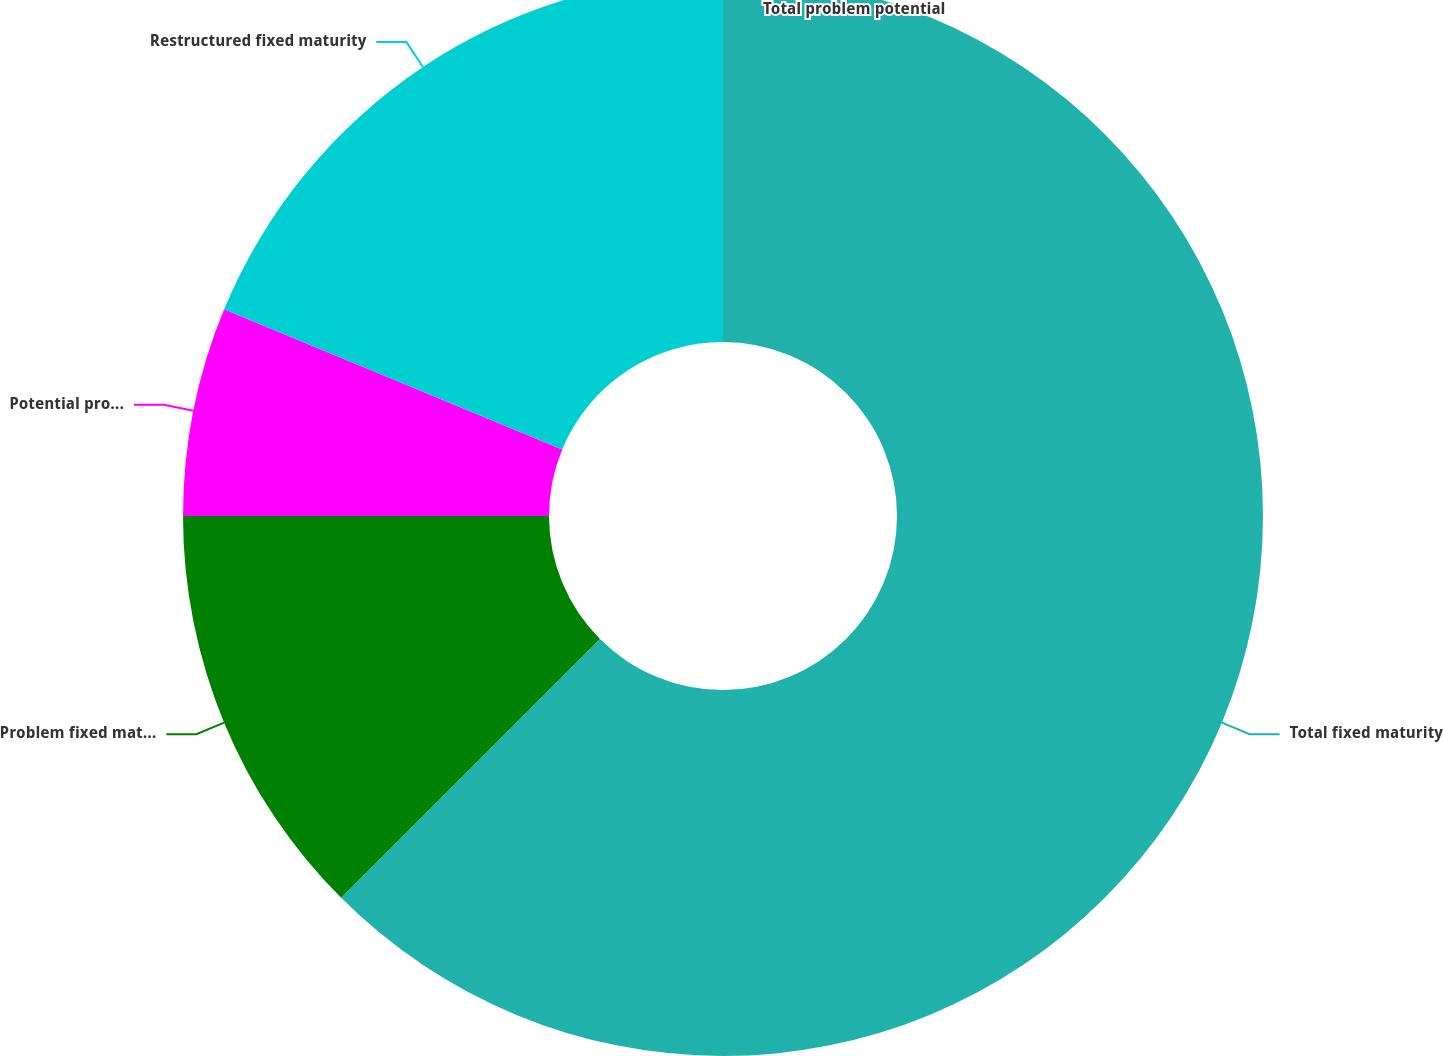Convert chart. <chart><loc_0><loc_0><loc_500><loc_500><pie_chart><fcel>Total fixed maturity<fcel>Problem fixed maturity<fcel>Potential problem fixed<fcel>Restructured fixed maturity<fcel>Total problem potential<nl><fcel>62.5%<fcel>12.5%<fcel>6.25%<fcel>18.75%<fcel>0.0%<nl></chart> 